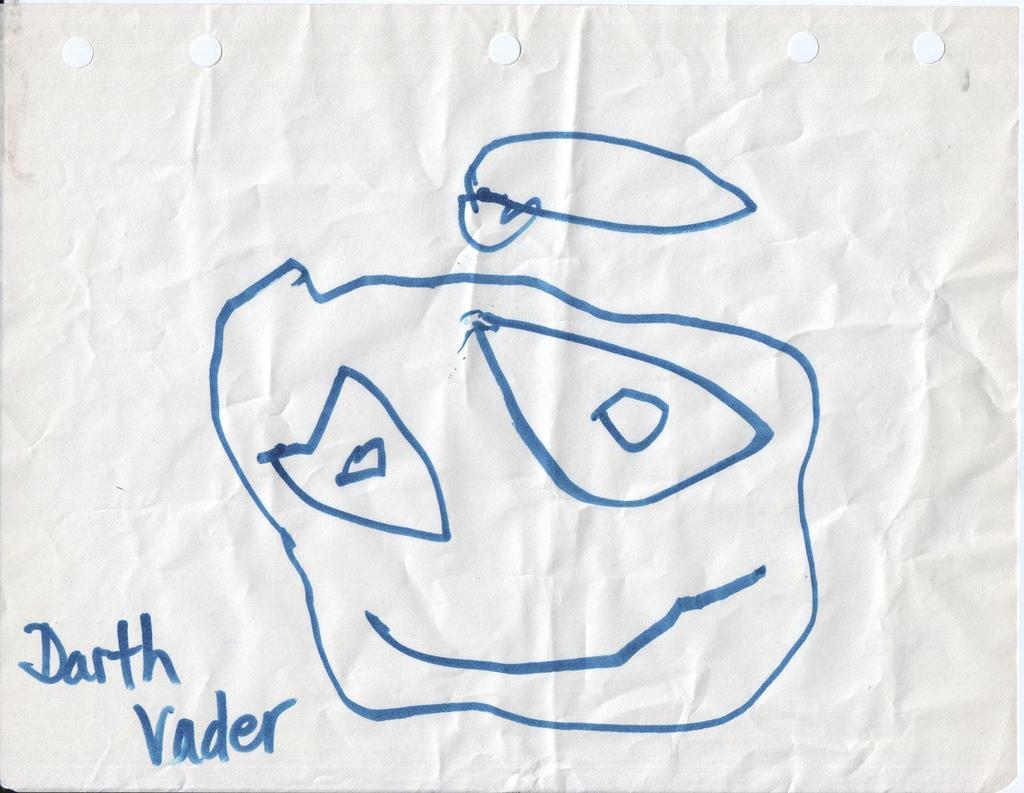Can you describe this image briefly? This picture consists of a paper on which there is a drawing. 